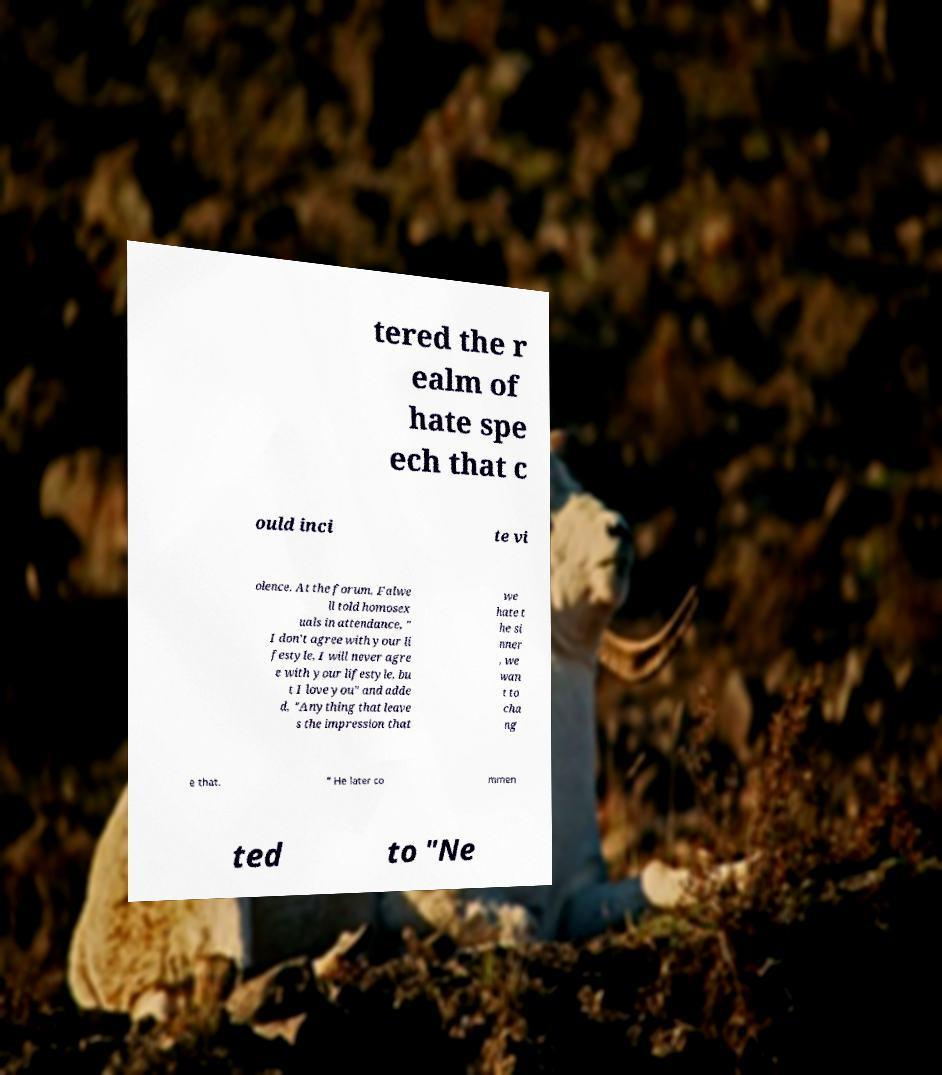There's text embedded in this image that I need extracted. Can you transcribe it verbatim? tered the r ealm of hate spe ech that c ould inci te vi olence. At the forum, Falwe ll told homosex uals in attendance, " I don't agree with your li festyle, I will never agre e with your lifestyle, bu t I love you" and adde d, "Anything that leave s the impression that we hate t he si nner , we wan t to cha ng e that. " He later co mmen ted to "Ne 